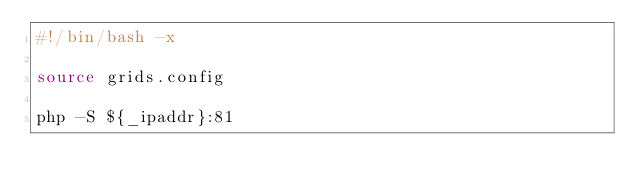Convert code to text. <code><loc_0><loc_0><loc_500><loc_500><_Bash_>#!/bin/bash -x

source grids.config

php -S ${_ipaddr}:81
</code> 